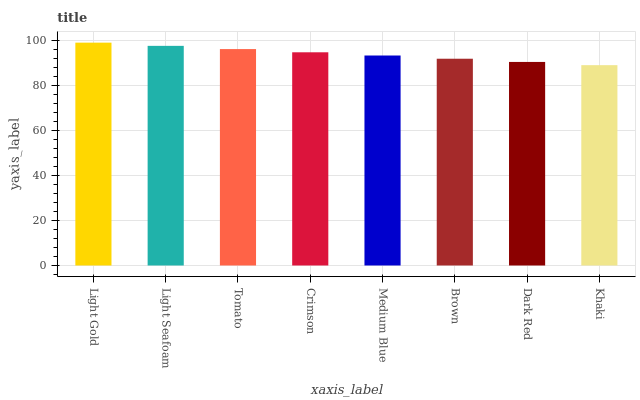Is Khaki the minimum?
Answer yes or no. Yes. Is Light Gold the maximum?
Answer yes or no. Yes. Is Light Seafoam the minimum?
Answer yes or no. No. Is Light Seafoam the maximum?
Answer yes or no. No. Is Light Gold greater than Light Seafoam?
Answer yes or no. Yes. Is Light Seafoam less than Light Gold?
Answer yes or no. Yes. Is Light Seafoam greater than Light Gold?
Answer yes or no. No. Is Light Gold less than Light Seafoam?
Answer yes or no. No. Is Crimson the high median?
Answer yes or no. Yes. Is Medium Blue the low median?
Answer yes or no. Yes. Is Light Gold the high median?
Answer yes or no. No. Is Khaki the low median?
Answer yes or no. No. 